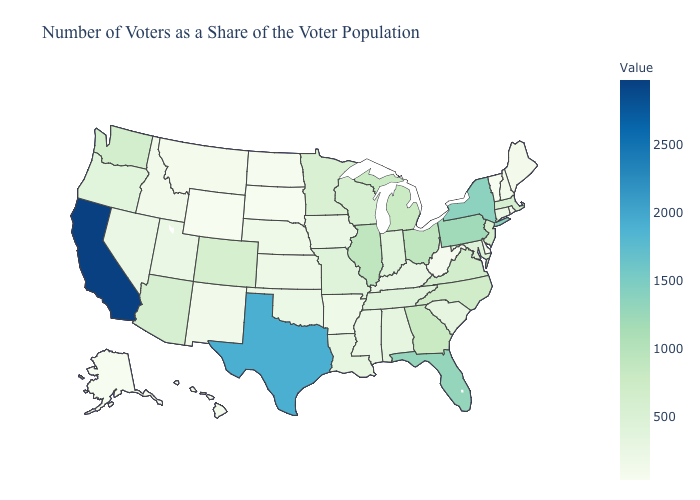Does West Virginia have the highest value in the USA?
Keep it brief. No. Does Oregon have the highest value in the USA?
Keep it brief. No. Among the states that border Virginia , which have the lowest value?
Concise answer only. West Virginia. 